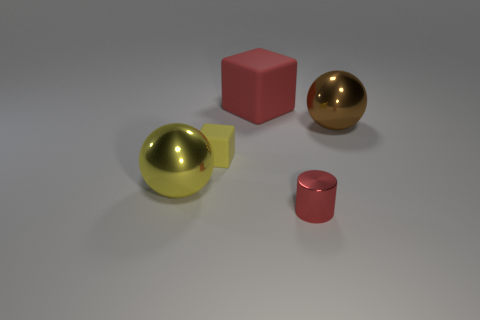What is the material of the two spheres? The two spheres look distinctly different in material. The sphere on the left has a matte surface that is not reflective, suggesting it is possibly made of rubber. The sphere on the right, however, has a highly reflective, glossy surface which is indicative of a polished metal finish. How can you tell the difference between the materials? Material appearance is often discerned by how light interacts with the surface. Matte surfaces, like that of the rubber sphere, scatter light, resulting in a non-reflective appearance. The metal sphere reflects light sharply giving it a mirror-like appearance, which is characteristic of shiny metallic objects. 